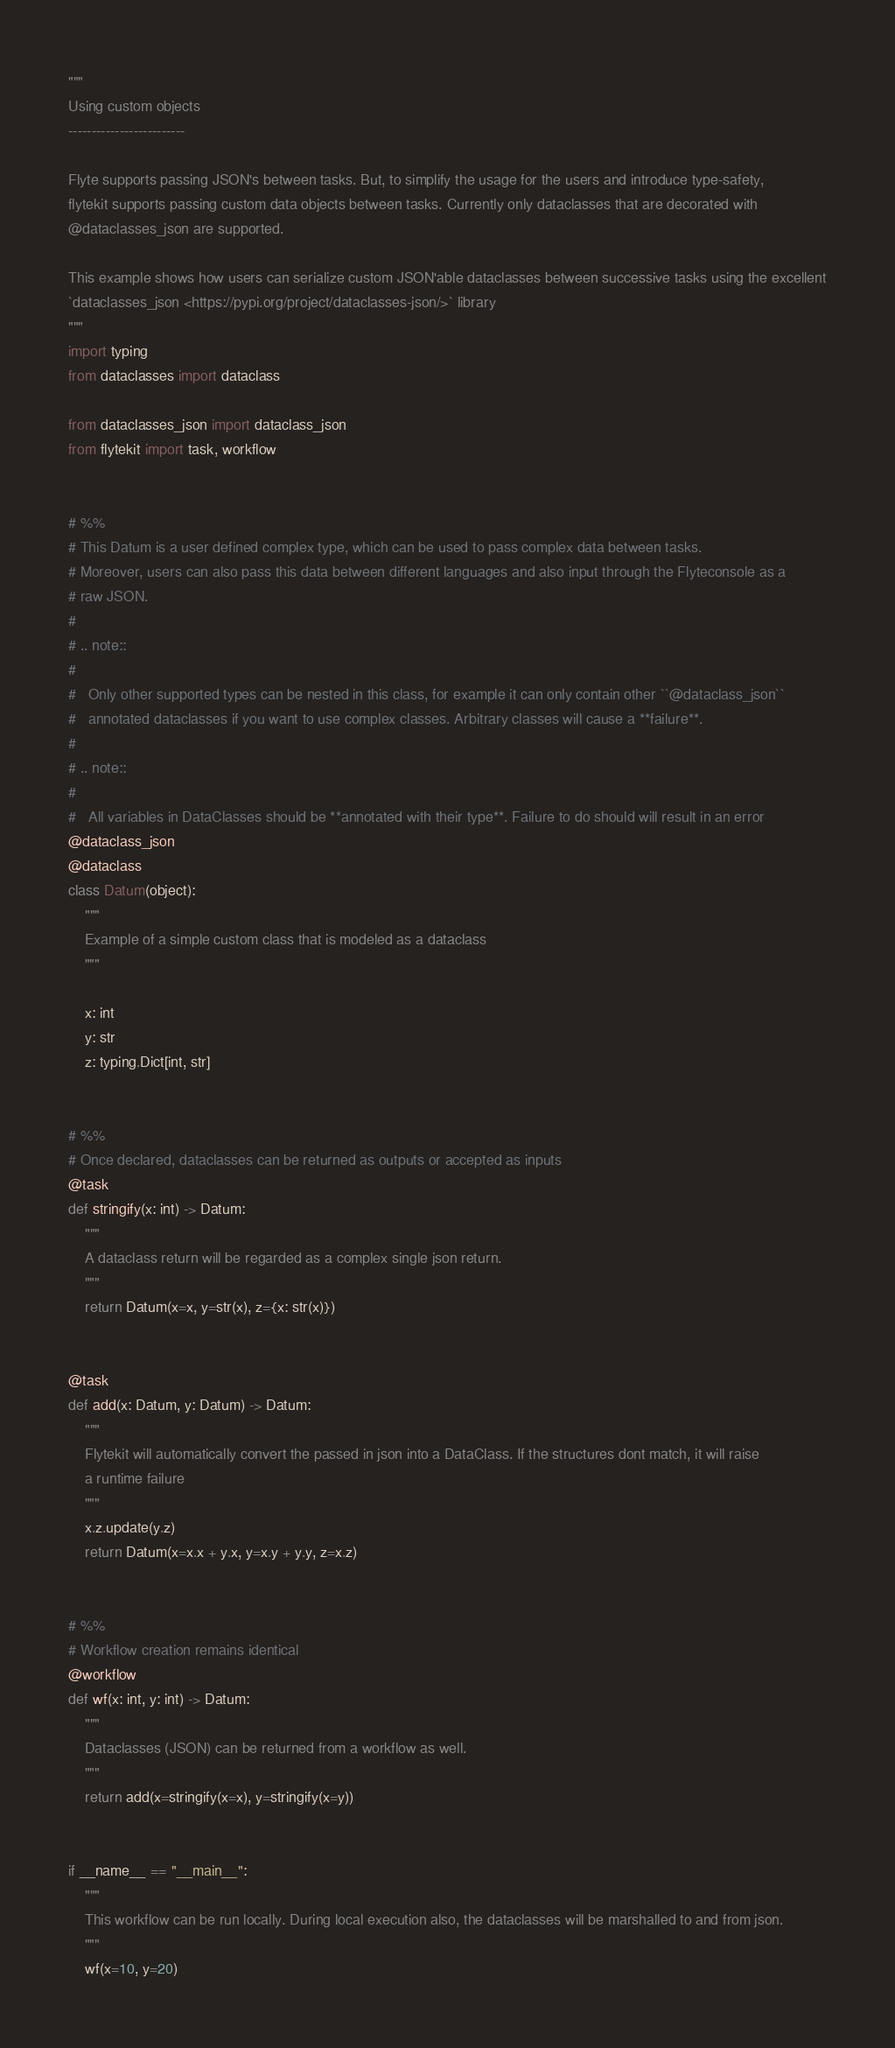Convert code to text. <code><loc_0><loc_0><loc_500><loc_500><_Python_>"""
Using custom objects
-------------------------

Flyte supports passing JSON's between tasks. But, to simplify the usage for the users and introduce type-safety,
flytekit supports passing custom data objects between tasks. Currently only dataclasses that are decorated with
@dataclasses_json are supported.

This example shows how users can serialize custom JSON'able dataclasses between successive tasks using the excellent
`dataclasses_json <https://pypi.org/project/dataclasses-json/>` library
"""
import typing
from dataclasses import dataclass

from dataclasses_json import dataclass_json
from flytekit import task, workflow


# %%
# This Datum is a user defined complex type, which can be used to pass complex data between tasks.
# Moreover, users can also pass this data between different languages and also input through the Flyteconsole as a
# raw JSON.
#
# .. note::
#
#   Only other supported types can be nested in this class, for example it can only contain other ``@dataclass_json``
#   annotated dataclasses if you want to use complex classes. Arbitrary classes will cause a **failure**.
#
# .. note::
#
#   All variables in DataClasses should be **annotated with their type**. Failure to do should will result in an error
@dataclass_json
@dataclass
class Datum(object):
    """
    Example of a simple custom class that is modeled as a dataclass
    """

    x: int
    y: str
    z: typing.Dict[int, str]


# %%
# Once declared, dataclasses can be returned as outputs or accepted as inputs
@task
def stringify(x: int) -> Datum:
    """
    A dataclass return will be regarded as a complex single json return.
    """
    return Datum(x=x, y=str(x), z={x: str(x)})


@task
def add(x: Datum, y: Datum) -> Datum:
    """
    Flytekit will automatically convert the passed in json into a DataClass. If the structures dont match, it will raise
    a runtime failure
    """
    x.z.update(y.z)
    return Datum(x=x.x + y.x, y=x.y + y.y, z=x.z)


# %%
# Workflow creation remains identical
@workflow
def wf(x: int, y: int) -> Datum:
    """
    Dataclasses (JSON) can be returned from a workflow as well.
    """
    return add(x=stringify(x=x), y=stringify(x=y))


if __name__ == "__main__":
    """
    This workflow can be run locally. During local execution also, the dataclasses will be marshalled to and from json.
    """
    wf(x=10, y=20)
</code> 